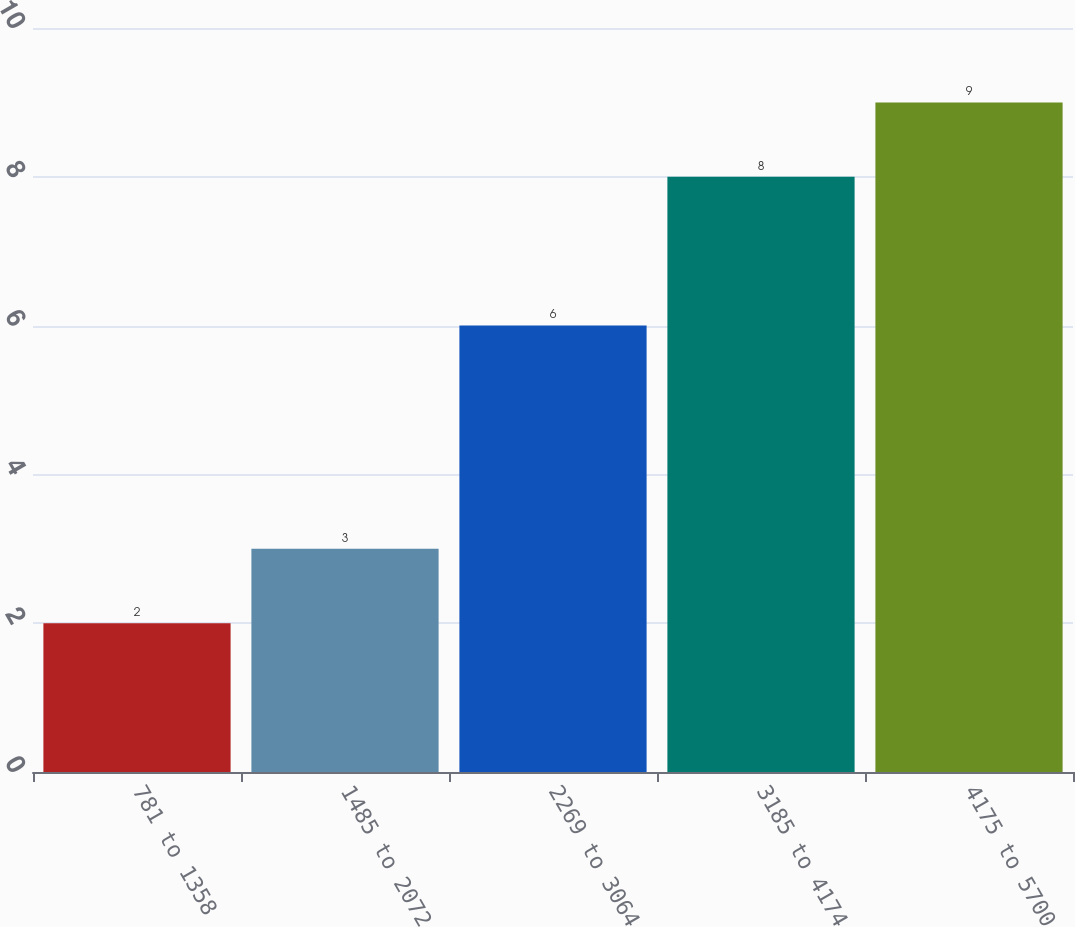Convert chart. <chart><loc_0><loc_0><loc_500><loc_500><bar_chart><fcel>781 to 1358<fcel>1485 to 2072<fcel>2269 to 3064<fcel>3185 to 4174<fcel>4175 to 5700<nl><fcel>2<fcel>3<fcel>6<fcel>8<fcel>9<nl></chart> 